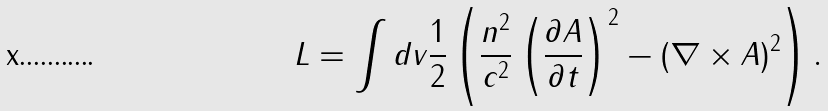Convert formula to latex. <formula><loc_0><loc_0><loc_500><loc_500>L = \int d v \frac { 1 } { 2 } \left ( \frac { n ^ { 2 } } { c ^ { 2 } } \left ( \frac { \partial { A } } { \partial t } \right ) ^ { 2 } - { ( \nabla \times { A } ) ^ { 2 } } \right ) .</formula> 